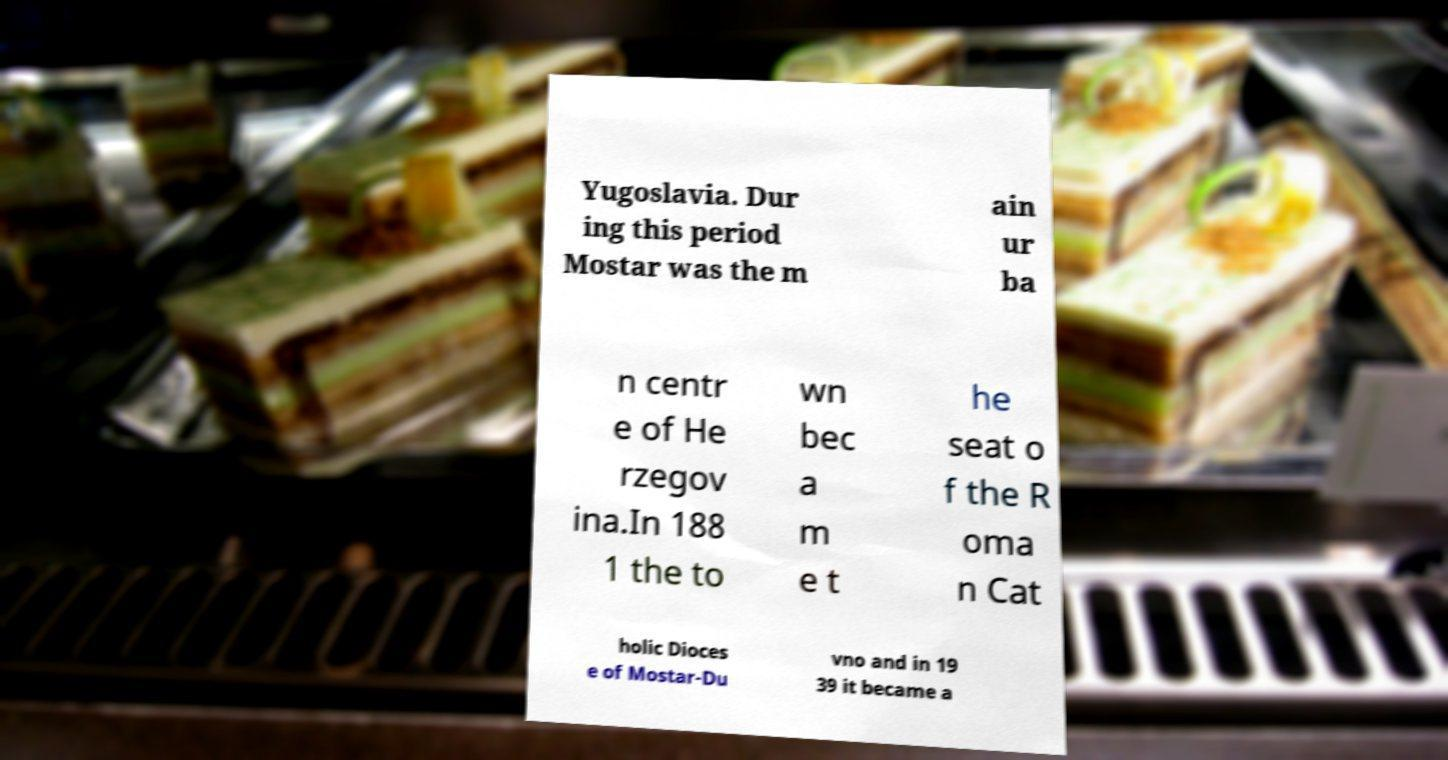Can you read and provide the text displayed in the image?This photo seems to have some interesting text. Can you extract and type it out for me? Yugoslavia. Dur ing this period Mostar was the m ain ur ba n centr e of He rzegov ina.In 188 1 the to wn bec a m e t he seat o f the R oma n Cat holic Dioces e of Mostar-Du vno and in 19 39 it became a 